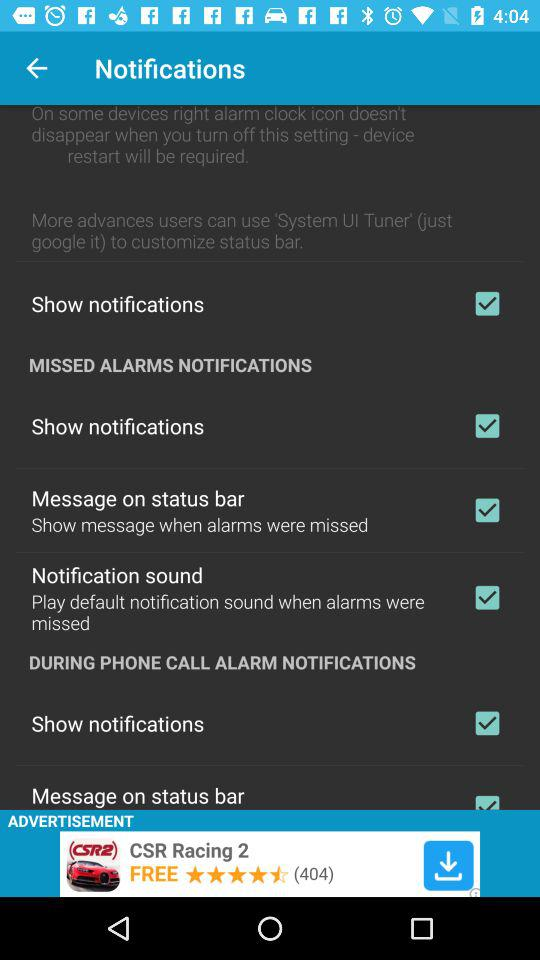What is the status of "Notification sound"? The status is "on". 